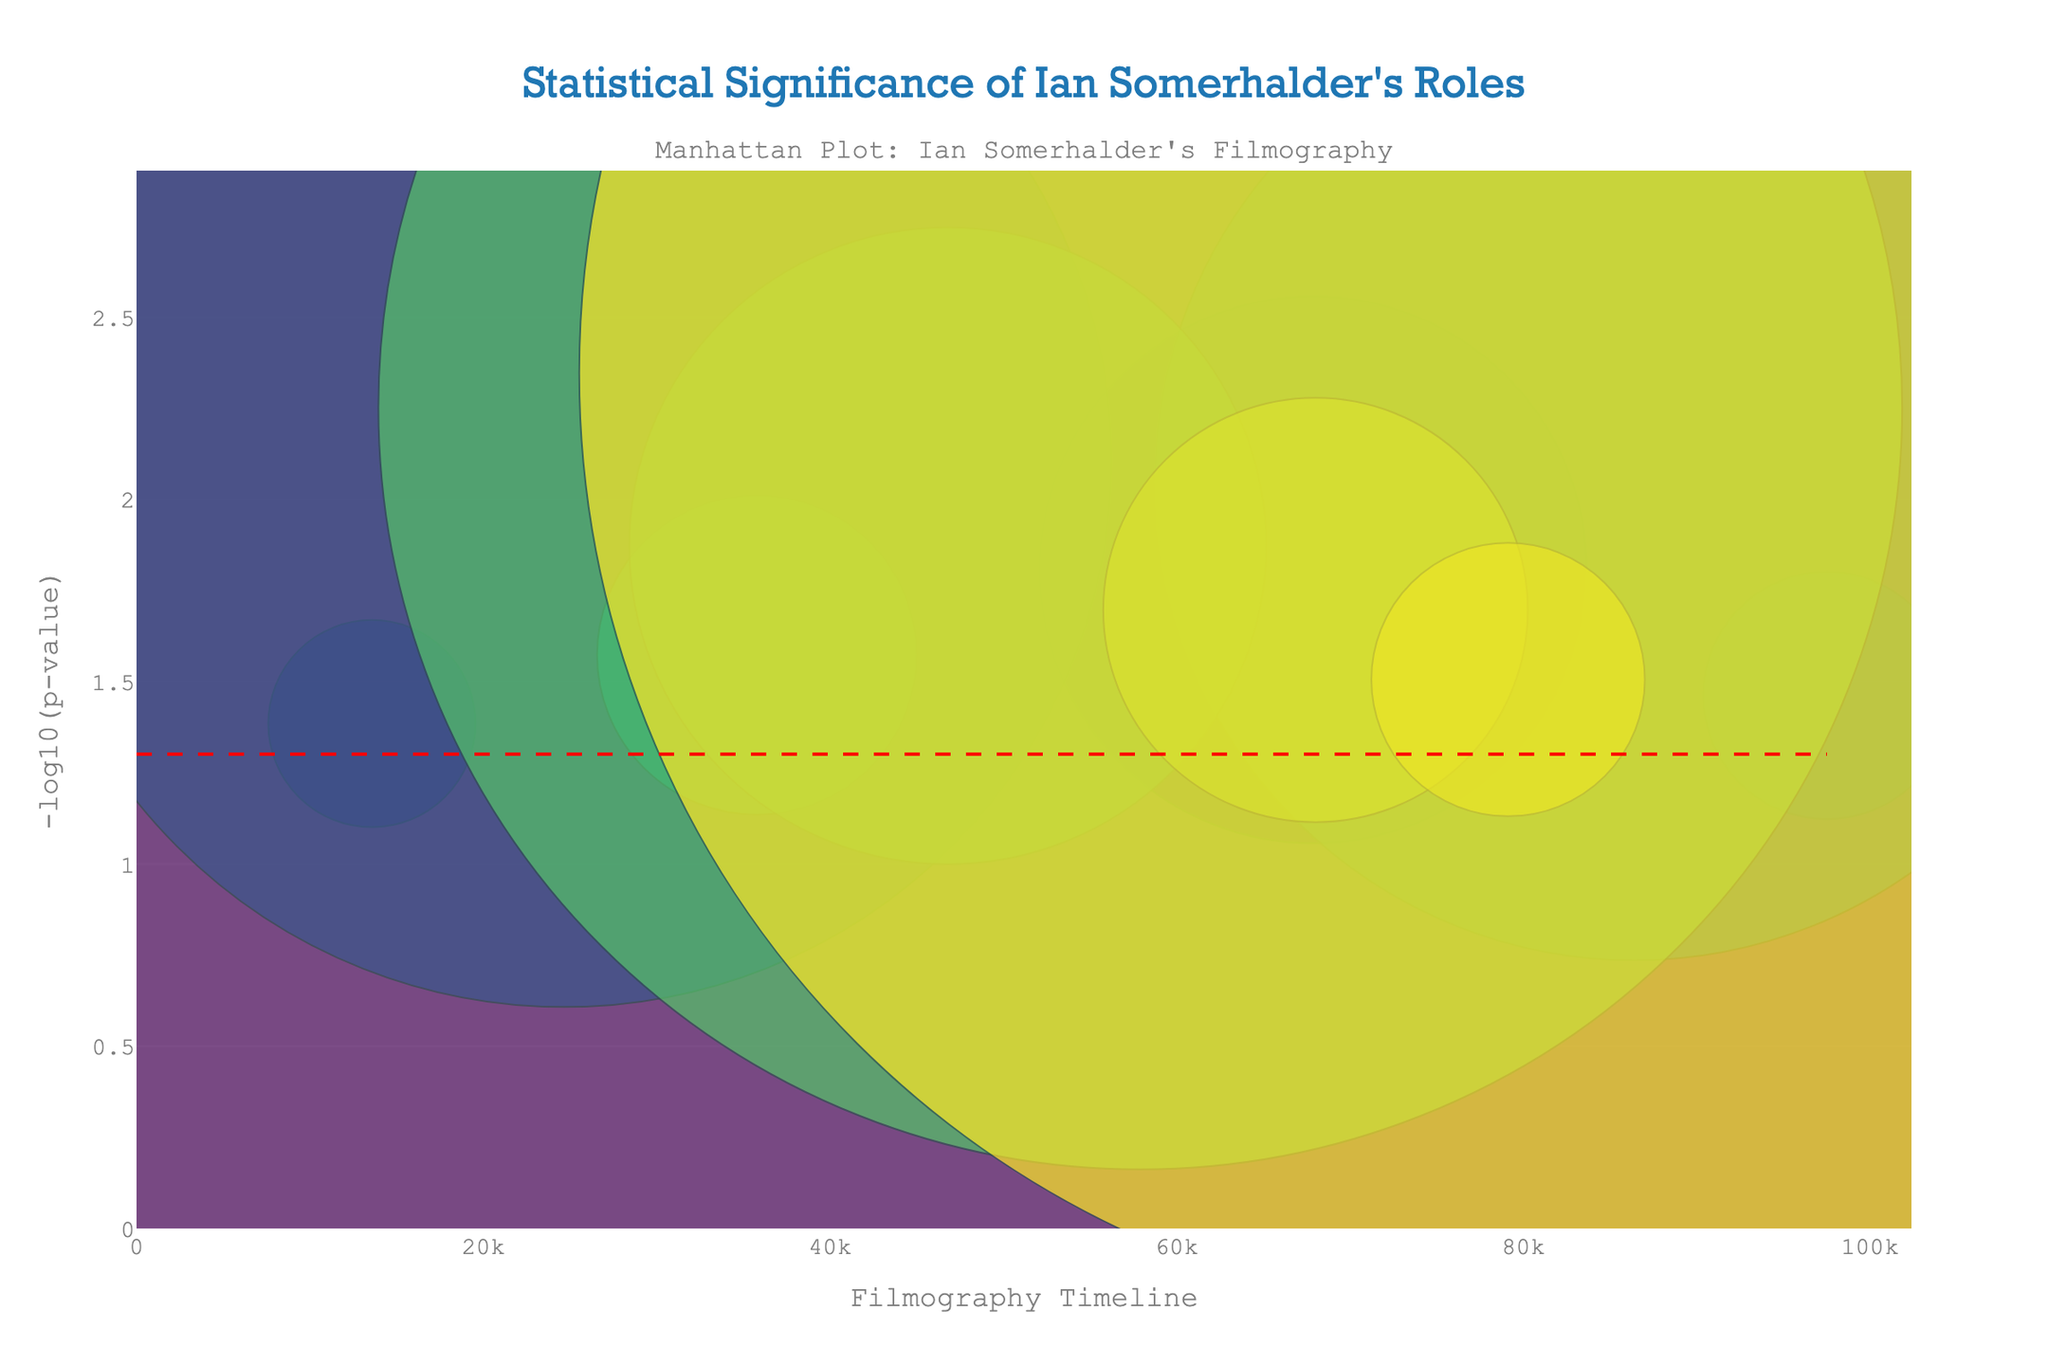what is the title of the plot? The title is prominently displayed at the top of the plot. It reads "Statistical Significance of Ian Somerhalder's Roles."
Answer: Statistical Significance of Ian Somerhalder's Roles How is the y-axis labeled? The y-axis label is written vertically along the left side of the plot. It reads "-log10(p-value)".
Answer: -log10(p-value) Which axis represents the filmography timeline? The x-axis represents the filmography timeline. This can be inferred from its label "Filmography Timeline" at the bottom of the plot.
Answer: x-axis What color line indicates the significance threshold? The significance threshold is indicated by a red dashed line. This can be seen running horizontally across the plot.
Answer: red dashed line Which role has the lowest p-value and what is it? The role with the lowest p-value is Damon Salvatore (The Vampire Diaries) with a p-value represented as the highest -log10(p) value. This can be found by identifying the highest point along the y-axis.
Answer: Damon Salvatore (The Vampire Diaries) How many roles have p-values below the significance threshold (p < 0.05)? To determine this, we count the number of data points that fall above the red threshold line on the y-axis.
Answer: 12 Compare the -log10(p-value) for Damon Salvatore in "The Vampire Diaries" and "The Vampire Diaries: A Darker Truth." Which one is higher? Identify both roles on the scatter plot and observe their corresponding -log10(p) values. The one placed higher along the y-axis has a higher value.
Answer: The Vampire Diaries: A Darker Truth What is the approximate range of the x-axis? The x-axis ranges can be estimated by observing the minimum and maximum values at the x-axis ends. From the given data, it starts from 0 and extends a little beyond the largest Position value.
Answer: 0 to approximately 71000 Which role falls closest to the significance threshold line? Identifying the role closest to the red dashed line involves finding the data point nearest to the threshold along the y-axis but not necessarily above it.
Answer: Aaron Corbett (Fallen) What is the -log10(p-value) for Hamilton Fleming in "Young Americans"? Find the data point marked with this role and observe its position along the y-axis. This value is directly given by its y position, translating the height into the -log10(p-value).
Answer: approximately 2.054 